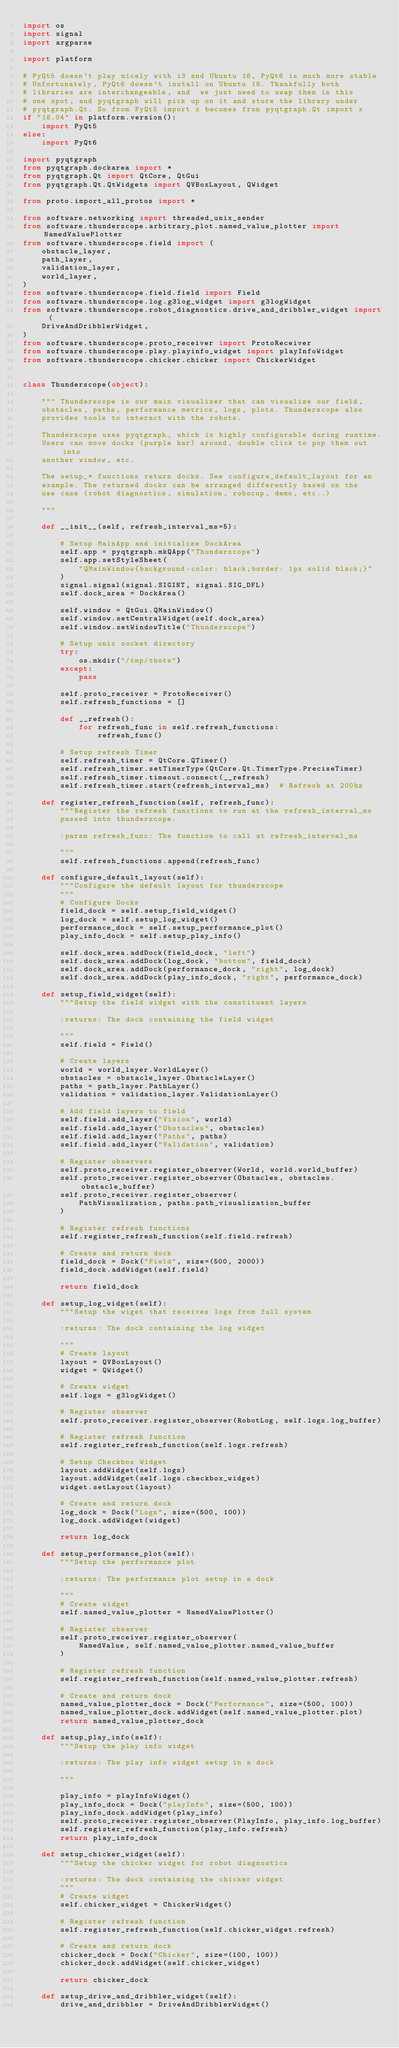<code> <loc_0><loc_0><loc_500><loc_500><_Python_>import os
import signal
import argparse

import platform

# PyQt5 doesn't play nicely with i3 and Ubuntu 18, PyQt6 is much more stable
# Unfortunately, PyQt6 doesn't install on Ubuntu 18. Thankfully both
# libraries are interchangeable, and  we just need to swap them in this
# one spot, and pyqtgraph will pick up on it and store the library under
# pyqtgraph.Qt. So from PyQt5 import x becomes from pyqtgraph.Qt import x
if "18.04" in platform.version():
    import PyQt5
else:
    import PyQt6

import pyqtgraph
from pyqtgraph.dockarea import *
from pyqtgraph.Qt import QtCore, QtGui
from pyqtgraph.Qt.QtWidgets import QVBoxLayout, QWidget

from proto.import_all_protos import *

from software.networking import threaded_unix_sender
from software.thunderscope.arbitrary_plot.named_value_plotter import NamedValuePlotter
from software.thunderscope.field import (
    obstacle_layer,
    path_layer,
    validation_layer,
    world_layer,
)
from software.thunderscope.field.field import Field
from software.thunderscope.log.g3log_widget import g3logWidget
from software.thunderscope.robot_diagnostics.drive_and_dribbler_widget import (
    DriveAndDribblerWidget,
)
from software.thunderscope.proto_receiver import ProtoReceiver
from software.thunderscope.play.playinfo_widget import playInfoWidget
from software.thunderscope.chicker.chicker import ChickerWidget


class Thunderscope(object):

    """ Thunderscope is our main visualizer that can visualize our field,
    obstacles, paths, performance metrics, logs, plots. Thunderscope also
    provides tools to interact with the robots.

    Thunderscope uses pyqtgraph, which is highly configurable during runtime.
    Users can move docks (purple bar) around, double click to pop them out into
    another window, etc.

    The setup_* functions return docks. See configure_default_layout for an
    example. The returned docks can be arranged differently based on the
    use case (robot diagnostics, simulation, robocup, demo, etc..)

    """

    def __init__(self, refresh_interval_ms=5):

        # Setup MainApp and initialize DockArea
        self.app = pyqtgraph.mkQApp("Thunderscope")
        self.app.setStyleSheet(
            "QMainWindow{background-color: black;border: 1px solid black;}"
        )
        signal.signal(signal.SIGINT, signal.SIG_DFL)
        self.dock_area = DockArea()

        self.window = QtGui.QMainWindow()
        self.window.setCentralWidget(self.dock_area)
        self.window.setWindowTitle("Thunderscope")

        # Setup unix socket directory
        try:
            os.mkdir("/tmp/tbots")
        except:
            pass

        self.proto_receiver = ProtoReceiver()
        self.refresh_functions = []

        def __refresh():
            for refresh_func in self.refresh_functions:
                refresh_func()

        # Setup refresh Timer
        self.refresh_timer = QtCore.QTimer()
        self.refresh_timer.setTimerType(QtCore.Qt.TimerType.PreciseTimer)
        self.refresh_timer.timeout.connect(__refresh)
        self.refresh_timer.start(refresh_interval_ms)  # Refresh at 200hz

    def register_refresh_function(self, refresh_func):
        """Register the refresh functions to run at the refresh_interval_ms
        passed into thunderscope.

        :param refresh_func: The function to call at refresh_interval_ms

        """
        self.refresh_functions.append(refresh_func)

    def configure_default_layout(self):
        """Configure the default layout for thunderscope
        """
        # Configure Docks
        field_dock = self.setup_field_widget()
        log_dock = self.setup_log_widget()
        performance_dock = self.setup_performance_plot()
        play_info_dock = self.setup_play_info()

        self.dock_area.addDock(field_dock, "left")
        self.dock_area.addDock(log_dock, "bottom", field_dock)
        self.dock_area.addDock(performance_dock, "right", log_dock)
        self.dock_area.addDock(play_info_dock, "right", performance_dock)

    def setup_field_widget(self):
        """Setup the field widget with the constituent layers

        :returns: The dock containing the field widget

        """
        self.field = Field()

        # Create layers
        world = world_layer.WorldLayer()
        obstacles = obstacle_layer.ObstacleLayer()
        paths = path_layer.PathLayer()
        validation = validation_layer.ValidationLayer()

        # Add field layers to field
        self.field.add_layer("Vision", world)
        self.field.add_layer("Obstacles", obstacles)
        self.field.add_layer("Paths", paths)
        self.field.add_layer("Validation", validation)

        # Register observers
        self.proto_receiver.register_observer(World, world.world_buffer)
        self.proto_receiver.register_observer(Obstacles, obstacles.obstacle_buffer)
        self.proto_receiver.register_observer(
            PathVisualization, paths.path_visualization_buffer
        )

        # Register refresh functions
        self.register_refresh_function(self.field.refresh)

        # Create and return dock
        field_dock = Dock("Field", size=(500, 2000))
        field_dock.addWidget(self.field)

        return field_dock

    def setup_log_widget(self):
        """Setup the wiget that receives logs from full system

        :returns: The dock containing the log widget

        """
        # Create layout
        layout = QVBoxLayout()
        widget = QWidget()

        # Create widget
        self.logs = g3logWidget()

        # Register observer
        self.proto_receiver.register_observer(RobotLog, self.logs.log_buffer)

        # Register refresh function
        self.register_refresh_function(self.logs.refresh)

        # Setup Checkbox Widget
        layout.addWidget(self.logs)
        layout.addWidget(self.logs.checkbox_widget)
        widget.setLayout(layout)

        # Create and return dock
        log_dock = Dock("Logs", size=(500, 100))
        log_dock.addWidget(widget)

        return log_dock

    def setup_performance_plot(self):
        """Setup the performance plot

        :returns: The performance plot setup in a dock

        """
        # Create widget
        self.named_value_plotter = NamedValuePlotter()

        # Register observer
        self.proto_receiver.register_observer(
            NamedValue, self.named_value_plotter.named_value_buffer
        )

        # Register refresh function
        self.register_refresh_function(self.named_value_plotter.refresh)

        # Create and return dock
        named_value_plotter_dock = Dock("Performance", size=(500, 100))
        named_value_plotter_dock.addWidget(self.named_value_plotter.plot)
        return named_value_plotter_dock

    def setup_play_info(self):
        """Setup the play info widget

        :returns: The play info widget setup in a dock

        """

        play_info = playInfoWidget()
        play_info_dock = Dock("playInfo", size=(500, 100))
        play_info_dock.addWidget(play_info)
        self.proto_receiver.register_observer(PlayInfo, play_info.log_buffer)
        self.register_refresh_function(play_info.refresh)
        return play_info_dock

    def setup_chicker_widget(self):
        """Setup the chicker widget for robot diagnostics

        :returns: The dock containing the chicker widget
        """
        # Create widget
        self.chicker_widget = ChickerWidget()

        # Register refresh function
        self.register_refresh_function(self.chicker_widget.refresh)

        # Create and return dock
        chicker_dock = Dock("Chicker", size=(100, 100))
        chicker_dock.addWidget(self.chicker_widget)

        return chicker_dock

    def setup_drive_and_dribbler_widget(self):
        drive_and_dribbler = DriveAndDribblerWidget()
</code> 